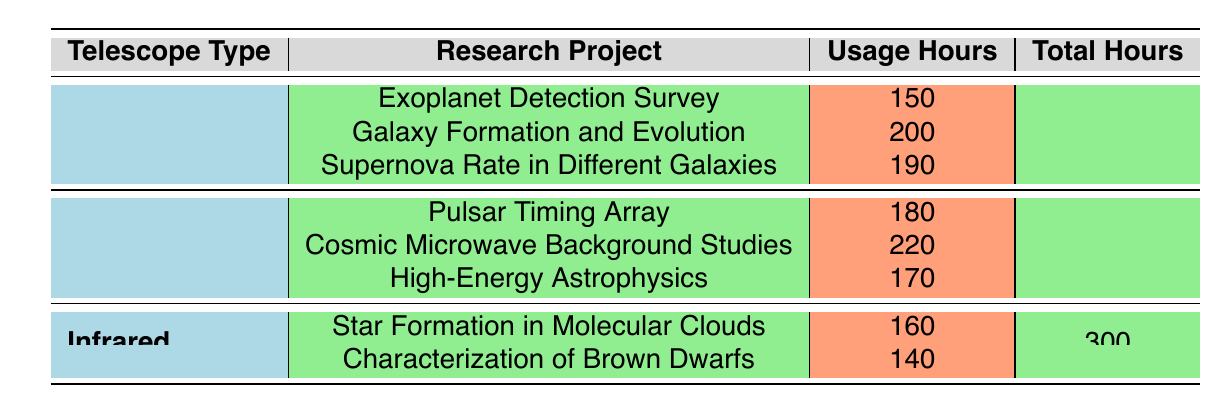What is the total usage hours for Optical telescopes? There are three projects under Optical telescopes with usage hours of 150, 200, and 190. To find the total, we sum these values: 150 + 200 + 190 = 540.
Answer: 540 Which research project had the highest usage hours with Radio telescopes? The projects under Radio telescopes have hours of 180, 220, and 170. The highest value is 220, which corresponds to the Cosmic Microwave Background Studies.
Answer: Cosmic Microwave Background Studies Is the usage hours for the Characterization of Brown Dwarfs greater than 150? The usage hours for Characterization of Brown Dwarfs is 140, which is less than 150. Therefore, the statement is false.
Answer: No What is the average usage hours for Infrared telescopes? There are two projects for Infrared telescopes with usage hours of 160 and 140. The total usage hours are 160 + 140 = 300. To find the average, we divide by the number of projects (2): 300 / 2 = 150.
Answer: 150 Which telescope type has the lowest total usage hours? The total usage hours for Optical is 540, Radio is 570, and Infrared is 300. Comparing these totals, Infrared has the lowest at 300.
Answer: Infrared What is the combined usage hours for the Exoplanet Detection Survey and Star Formation in Molecular Clouds? The usage hours for Exoplanet Detection Survey is 150, and for Star Formation in Molecular Clouds is 160. The combined total is 150 + 160 = 310.
Answer: 310 Did any projects use more than 200 hours? The projects are Exoplanet Detection Survey (150), Galaxy Formation and Evolution (200), Pulsar Timing Array (180), Cosmic Microwave Background Studies (220), High-Energy Astrophysics (170), Star Formation in Molecular Clouds (160), and Characterization of Brown Dwarfs (140). Only Cosmic Microwave Background Studies used more than 200 hours.
Answer: Yes How many projects used more than 160 hours? The projects with more than 160 usage hours are Galaxy Formation and Evolution (200), Cosmic Microwave Background Studies (220), and Supernova Rate in Different Galaxies (190). Thus, there are three projects that meet this criterion.
Answer: 3 What is the difference in total usage hours between Radio and Infrared telescopes? The total usage hours for Radio telescopes is 570 and for Infrared telescopes is 300. To find the difference, we subtract: 570 - 300 = 270.
Answer: 270 